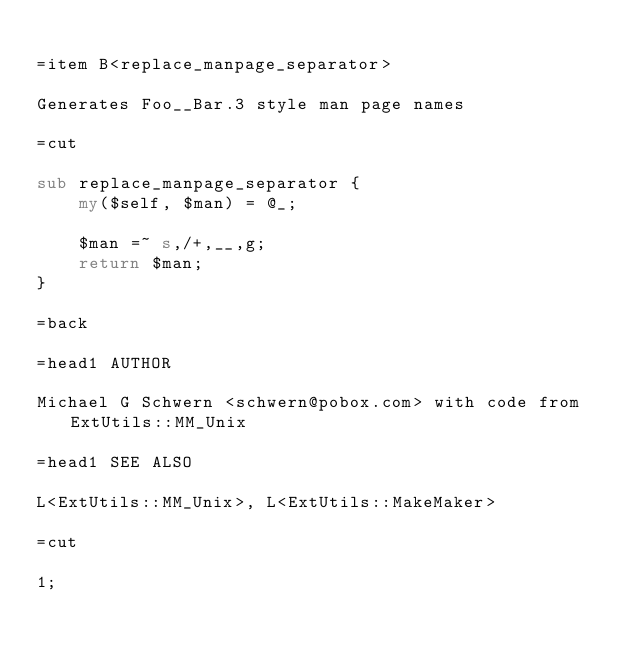<code> <loc_0><loc_0><loc_500><loc_500><_Perl_>
=item B<replace_manpage_separator>

Generates Foo__Bar.3 style man page names

=cut

sub replace_manpage_separator {
    my($self, $man) = @_;

    $man =~ s,/+,__,g;
    return $man;
}

=back

=head1 AUTHOR

Michael G Schwern <schwern@pobox.com> with code from ExtUtils::MM_Unix

=head1 SEE ALSO

L<ExtUtils::MM_Unix>, L<ExtUtils::MakeMaker>

=cut

1;
</code> 